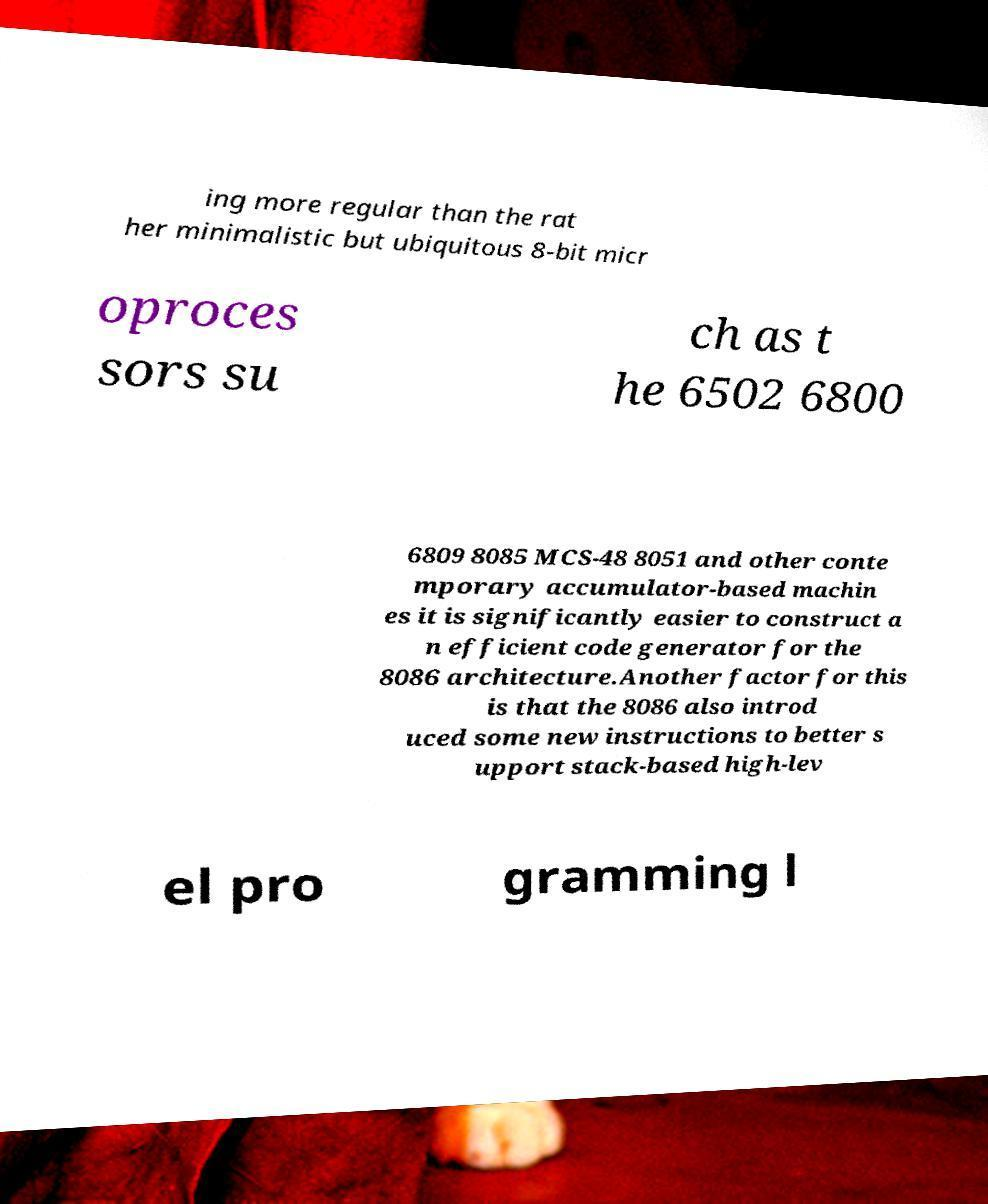Could you extract and type out the text from this image? ing more regular than the rat her minimalistic but ubiquitous 8-bit micr oproces sors su ch as t he 6502 6800 6809 8085 MCS-48 8051 and other conte mporary accumulator-based machin es it is significantly easier to construct a n efficient code generator for the 8086 architecture.Another factor for this is that the 8086 also introd uced some new instructions to better s upport stack-based high-lev el pro gramming l 